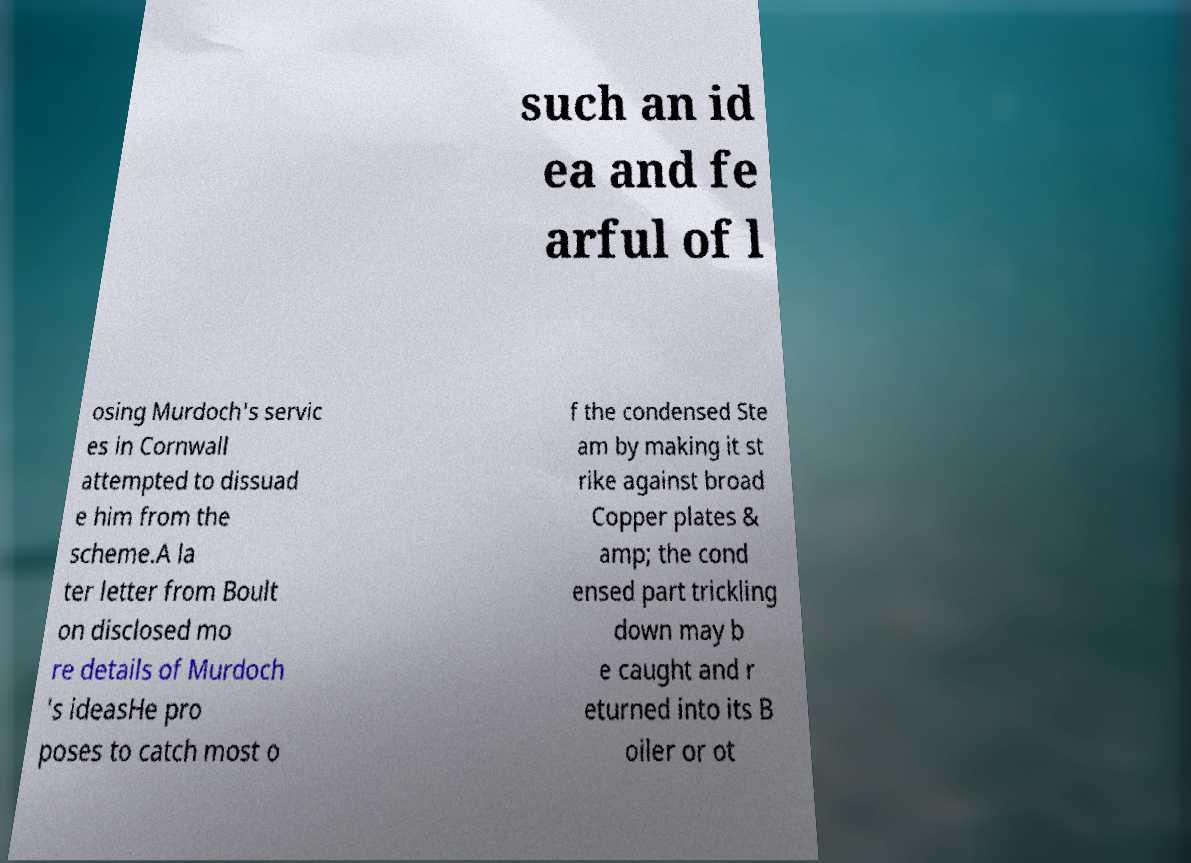Can you accurately transcribe the text from the provided image for me? such an id ea and fe arful of l osing Murdoch's servic es in Cornwall attempted to dissuad e him from the scheme.A la ter letter from Boult on disclosed mo re details of Murdoch 's ideasHe pro poses to catch most o f the condensed Ste am by making it st rike against broad Copper plates & amp; the cond ensed part trickling down may b e caught and r eturned into its B oiler or ot 